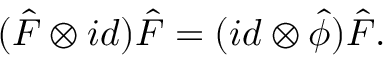Convert formula to latex. <formula><loc_0><loc_0><loc_500><loc_500>( \hat { F } \otimes i d ) \hat { F } = ( i d \otimes { \hat { \phi } } ) \hat { F } .</formula> 